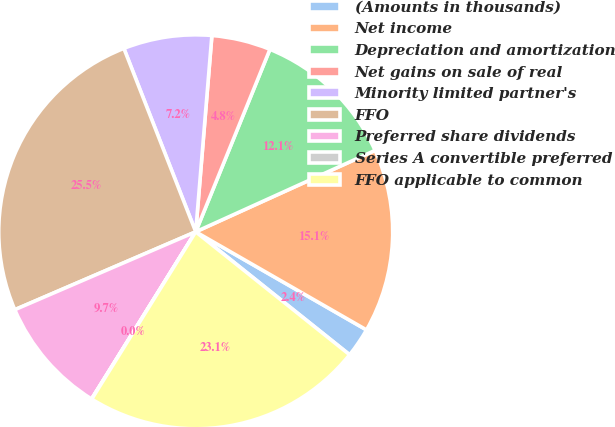<chart> <loc_0><loc_0><loc_500><loc_500><pie_chart><fcel>(Amounts in thousands)<fcel>Net income<fcel>Depreciation and amortization<fcel>Net gains on sale of real<fcel>Minority limited partner's<fcel>FFO<fcel>Preferred share dividends<fcel>Series A convertible preferred<fcel>FFO applicable to common<nl><fcel>2.43%<fcel>15.08%<fcel>12.07%<fcel>4.84%<fcel>7.25%<fcel>25.53%<fcel>9.66%<fcel>0.02%<fcel>23.12%<nl></chart> 